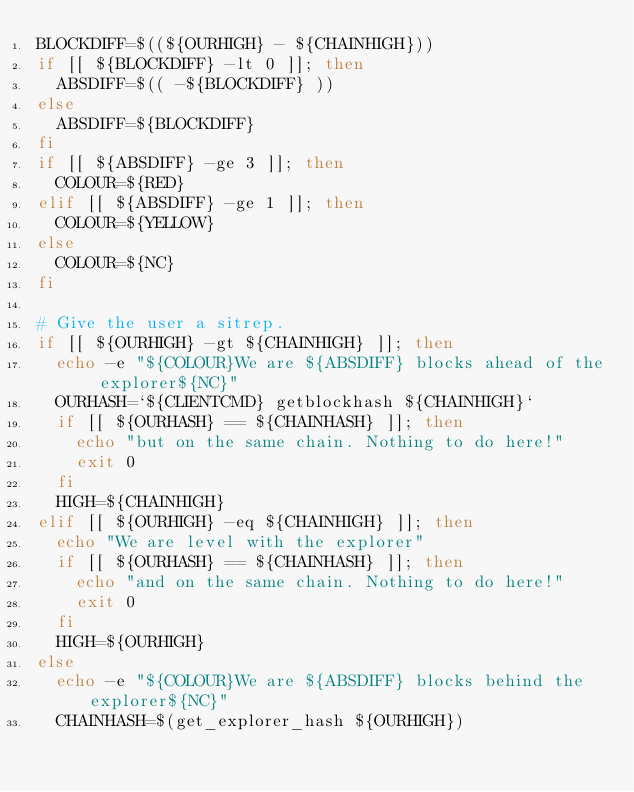<code> <loc_0><loc_0><loc_500><loc_500><_Bash_>BLOCKDIFF=$((${OURHIGH} - ${CHAINHIGH}))
if [[ ${BLOCKDIFF} -lt 0 ]]; then
  ABSDIFF=$(( -${BLOCKDIFF} ))
else
  ABSDIFF=${BLOCKDIFF}
fi
if [[ ${ABSDIFF} -ge 3 ]]; then
  COLOUR=${RED}
elif [[ ${ABSDIFF} -ge 1 ]]; then
  COLOUR=${YELLOW}
else
  COLOUR=${NC}
fi

# Give the user a sitrep.
if [[ ${OURHIGH} -gt ${CHAINHIGH} ]]; then
  echo -e "${COLOUR}We are ${ABSDIFF} blocks ahead of the explorer${NC}"
  OURHASH=`${CLIENTCMD} getblockhash ${CHAINHIGH}`
  if [[ ${OURHASH} == ${CHAINHASH} ]]; then
    echo "but on the same chain. Nothing to do here!"
    exit 0
  fi
  HIGH=${CHAINHIGH}
elif [[ ${OURHIGH} -eq ${CHAINHIGH} ]]; then
  echo "We are level with the explorer"
  if [[ ${OURHASH} == ${CHAINHASH} ]]; then
    echo "and on the same chain. Nothing to do here!"
    exit 0
  fi
  HIGH=${OURHIGH}
else
  echo -e "${COLOUR}We are ${ABSDIFF} blocks behind the explorer${NC}"
  CHAINHASH=$(get_explorer_hash ${OURHIGH})</code> 